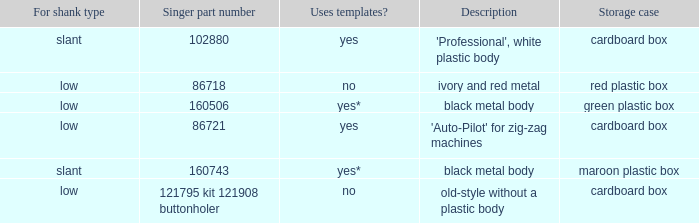What are all the different descriptions for the buttonholer with cardboard box for storage and a low shank type? 'Auto-Pilot' for zig-zag machines, old-style without a plastic body. 